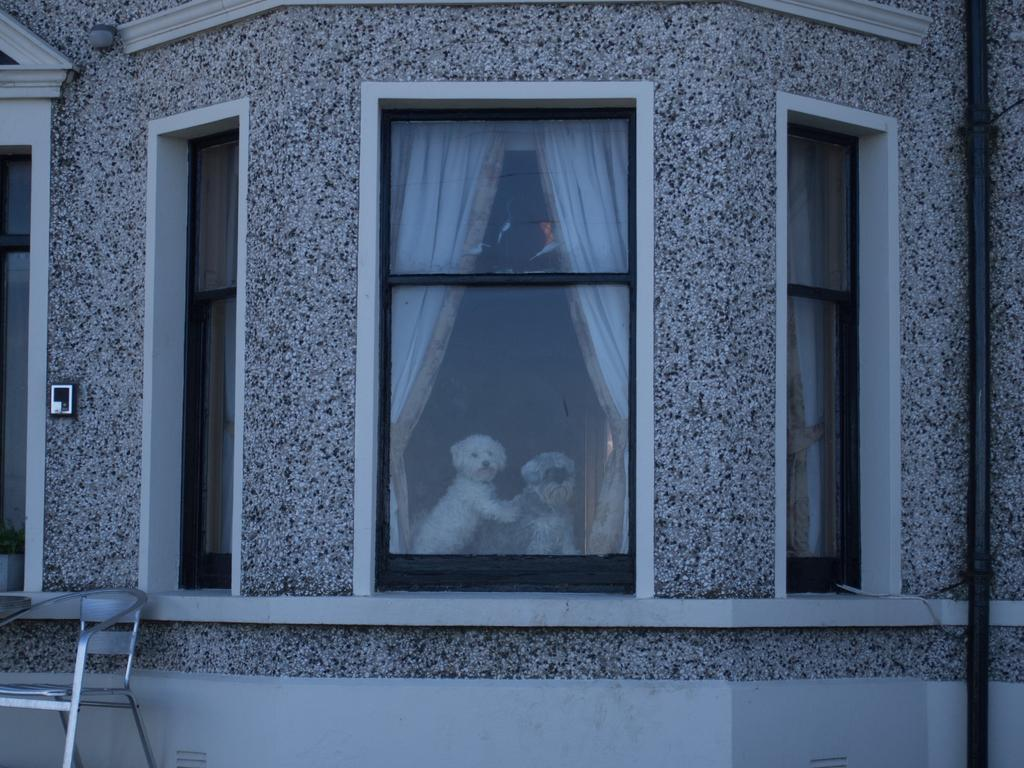What is the main structure in the picture? There is a building in the picture. What feature can be seen on the building? The building has windows. What is inside the windows? White curtains are present in the windows. What animals are in the picture? Two dogs are looking through the window. Where is a piece of furniture located in the picture? There is a chair in the left bottom of the picture. What type of pancake is being served in the battle depicted in the image? There is no battle or pancake present in the image; it features a building with dogs looking through the window and a chair in the left bottom. 